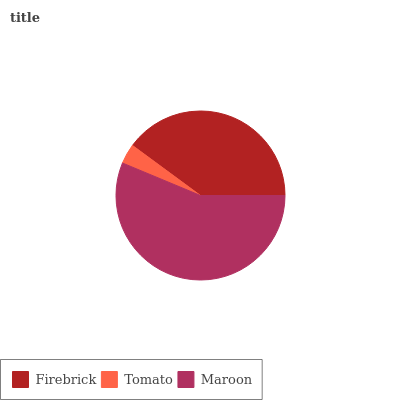Is Tomato the minimum?
Answer yes or no. Yes. Is Maroon the maximum?
Answer yes or no. Yes. Is Maroon the minimum?
Answer yes or no. No. Is Tomato the maximum?
Answer yes or no. No. Is Maroon greater than Tomato?
Answer yes or no. Yes. Is Tomato less than Maroon?
Answer yes or no. Yes. Is Tomato greater than Maroon?
Answer yes or no. No. Is Maroon less than Tomato?
Answer yes or no. No. Is Firebrick the high median?
Answer yes or no. Yes. Is Firebrick the low median?
Answer yes or no. Yes. Is Tomato the high median?
Answer yes or no. No. Is Maroon the low median?
Answer yes or no. No. 